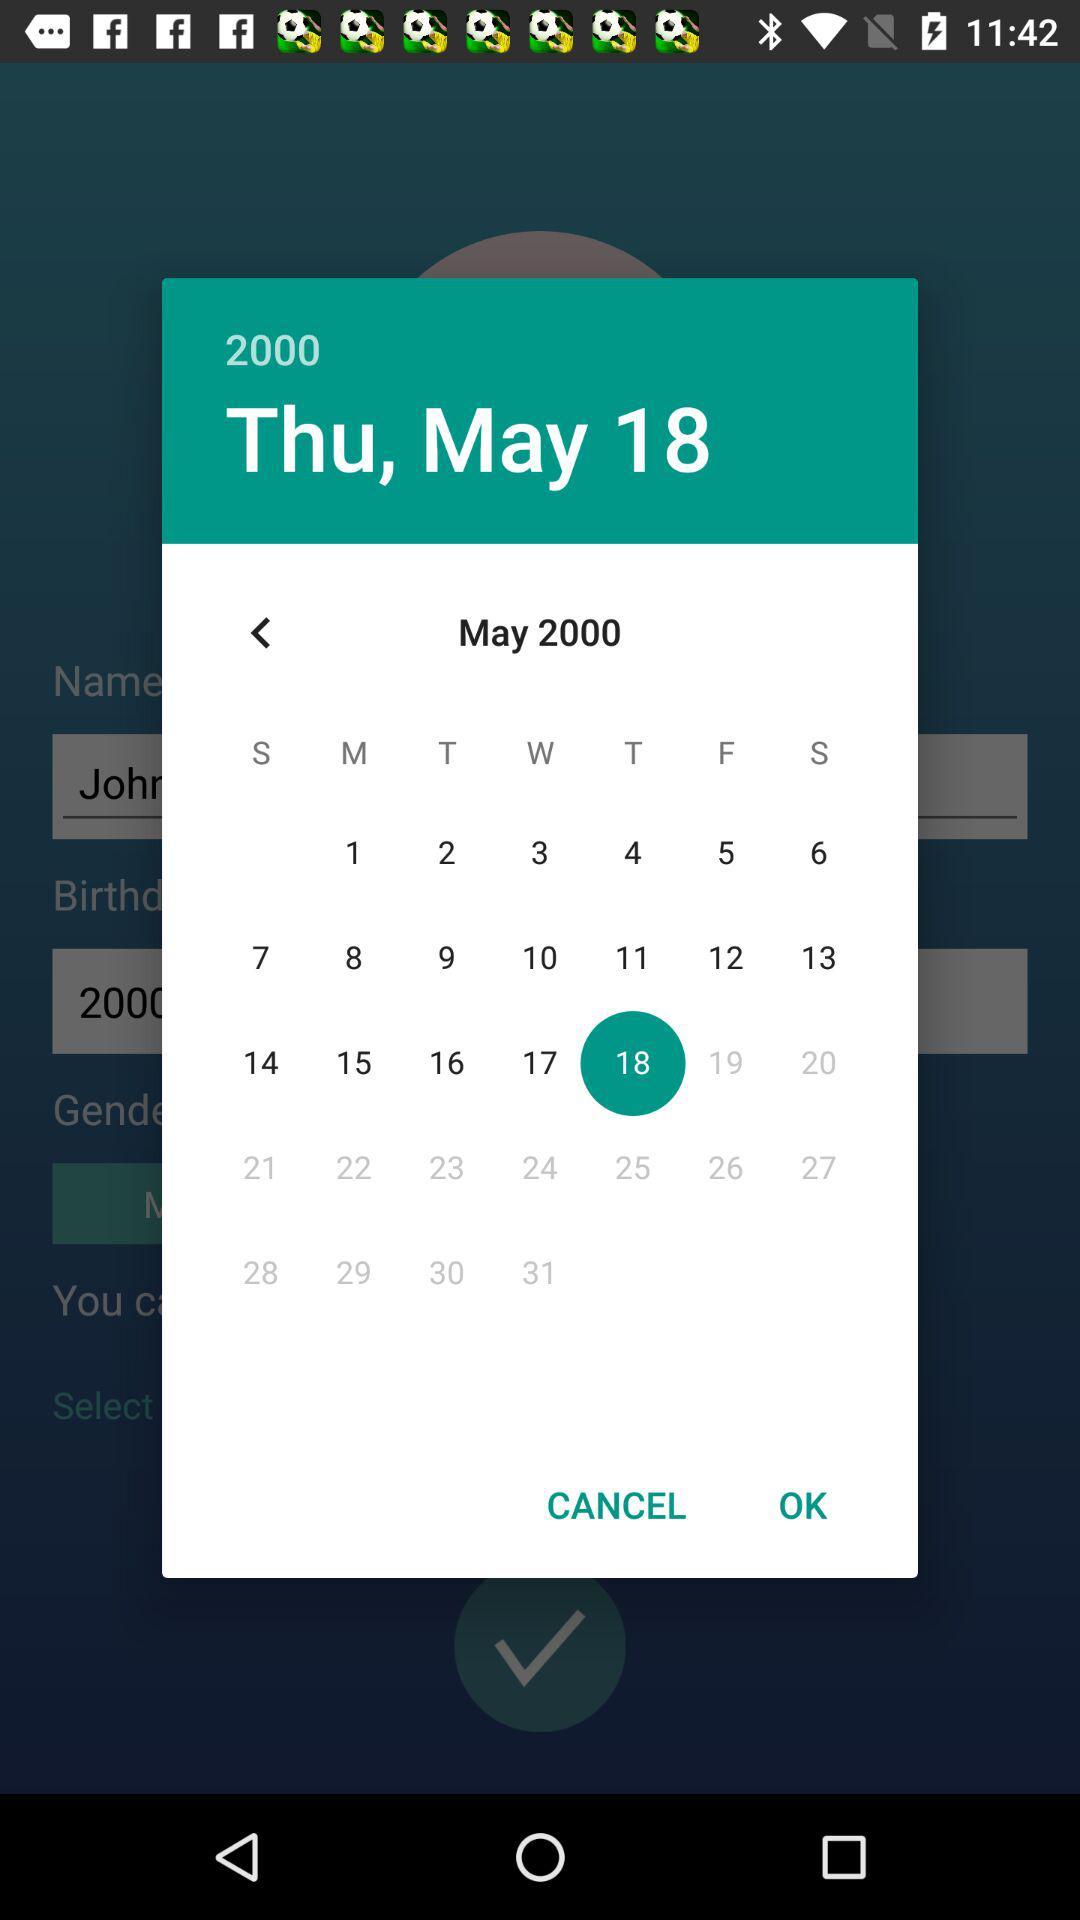What is the selected date? The selected date is Thursday, May 18, 2000. 